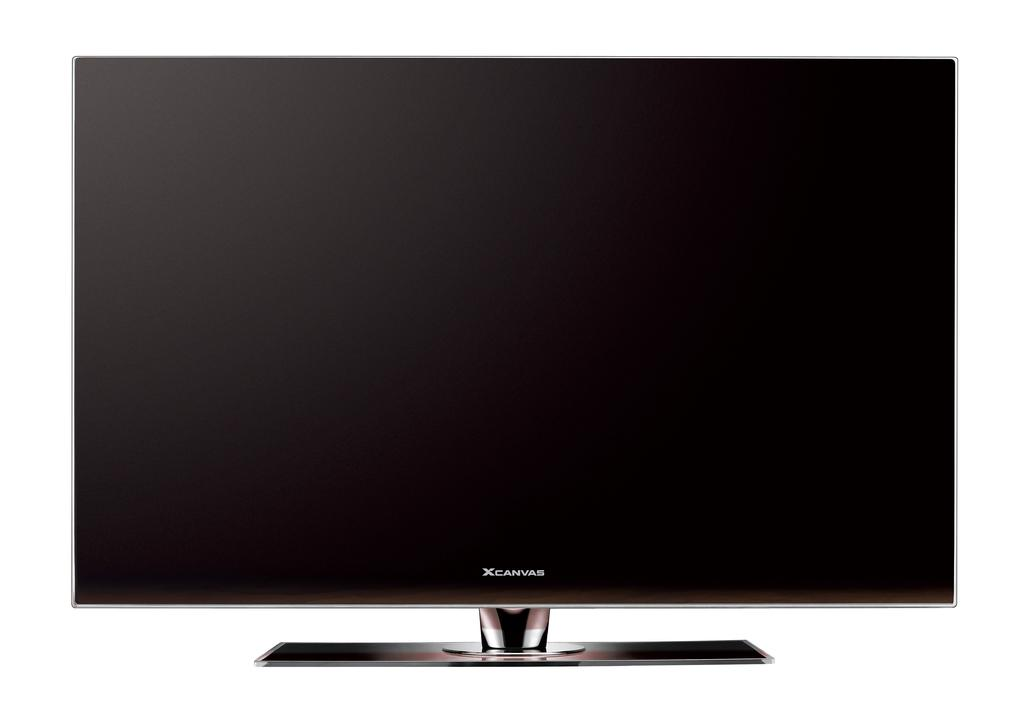<image>
Describe the image concisely. The brand of the television is a XCANVAS. 